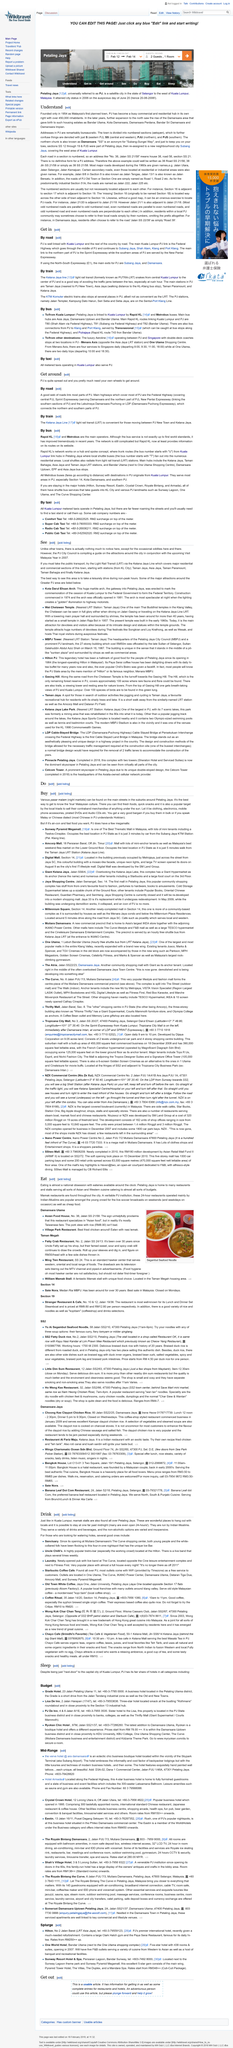Specify some key components in this picture. The town of PJ has over 450,000 inhabitants, and I would like to know how many inhabitants the town of PJ has. PJ, a town located in Malaysia, was founded in the year 1954. The northern chunk of PJ is also known as Damansara. 